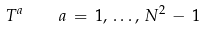Convert formula to latex. <formula><loc_0><loc_0><loc_500><loc_500>T ^ { a } \quad a \, = \, 1 , \, \dots , \, N ^ { 2 } \, - \, 1</formula> 